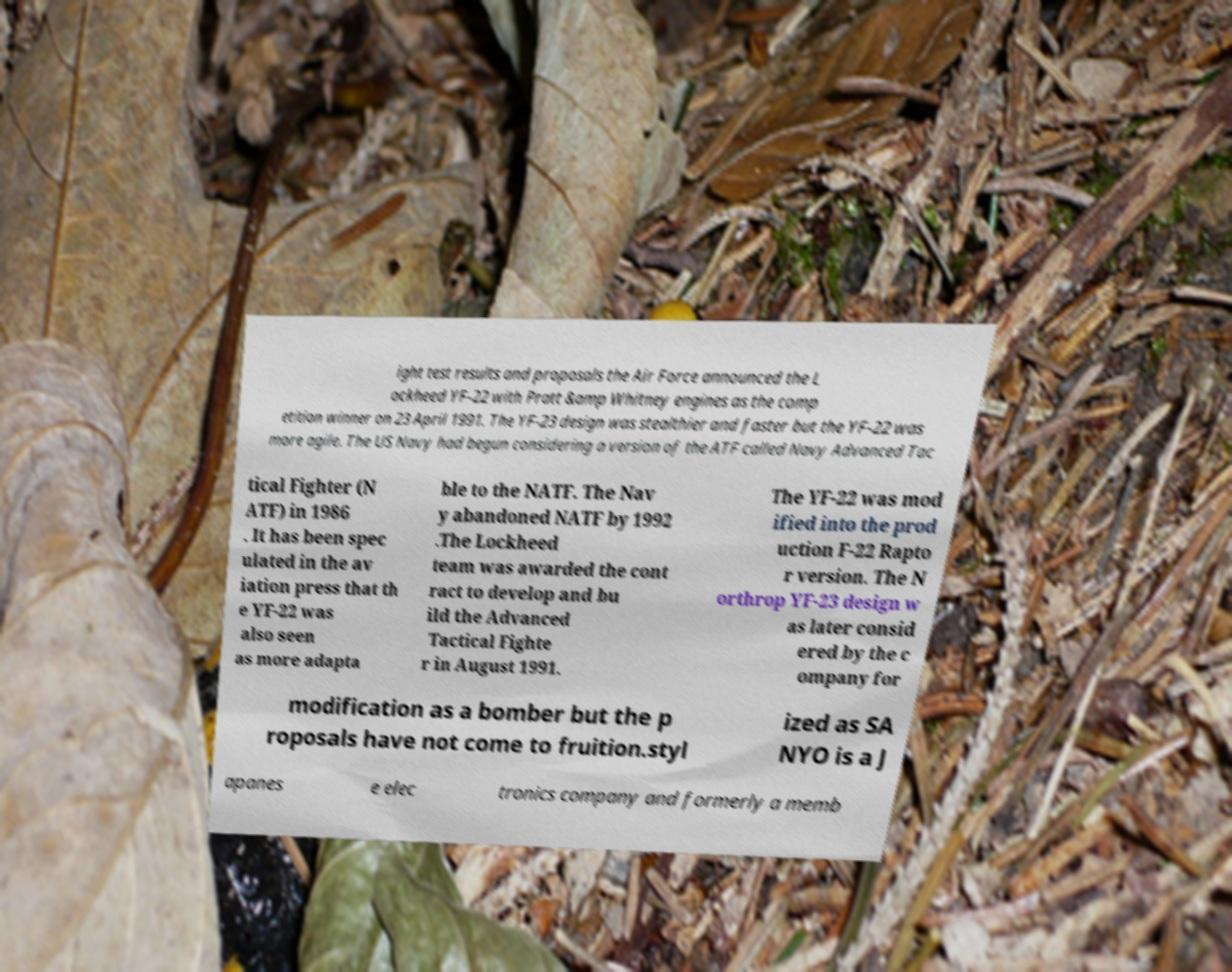Can you read and provide the text displayed in the image?This photo seems to have some interesting text. Can you extract and type it out for me? ight test results and proposals the Air Force announced the L ockheed YF-22 with Pratt &amp Whitney engines as the comp etition winner on 23 April 1991. The YF-23 design was stealthier and faster but the YF-22 was more agile. The US Navy had begun considering a version of the ATF called Navy Advanced Tac tical Fighter (N ATF) in 1986 . It has been spec ulated in the av iation press that th e YF-22 was also seen as more adapta ble to the NATF. The Nav y abandoned NATF by 1992 .The Lockheed team was awarded the cont ract to develop and bu ild the Advanced Tactical Fighte r in August 1991. The YF-22 was mod ified into the prod uction F-22 Rapto r version. The N orthrop YF-23 design w as later consid ered by the c ompany for modification as a bomber but the p roposals have not come to fruition.styl ized as SA NYO is a J apanes e elec tronics company and formerly a memb 